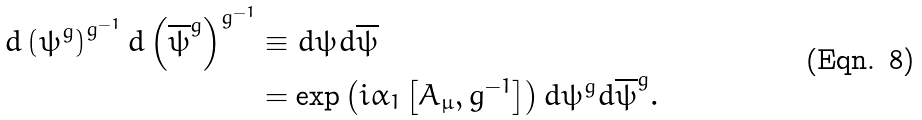Convert formula to latex. <formula><loc_0><loc_0><loc_500><loc_500>d \left ( \psi ^ { g } \right ) ^ { g ^ { - 1 } } d \left ( \overline { \psi } ^ { g } \right ) ^ { g ^ { - 1 } } & \equiv d \psi d { \overline { \psi } } \\ & = \exp \left ( i \alpha _ { 1 } \left [ A _ { \mu } , g ^ { - 1 } \right ] \right ) d \psi ^ { g } d { \overline { \psi } } ^ { g } .</formula> 